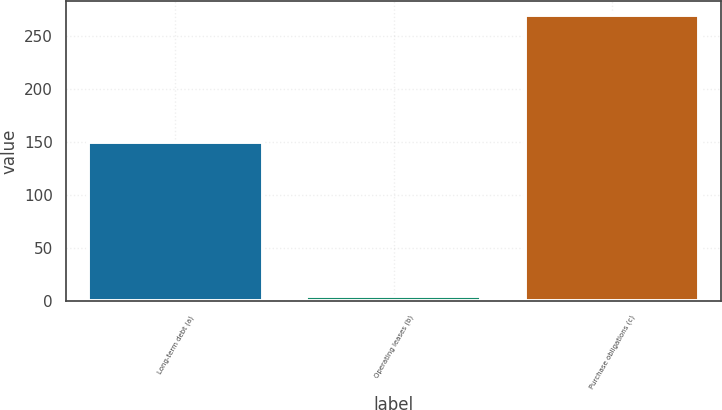Convert chart. <chart><loc_0><loc_0><loc_500><loc_500><bar_chart><fcel>Long-term debt (a)<fcel>Operating leases (b)<fcel>Purchase obligations (c)<nl><fcel>150<fcel>5<fcel>269<nl></chart> 